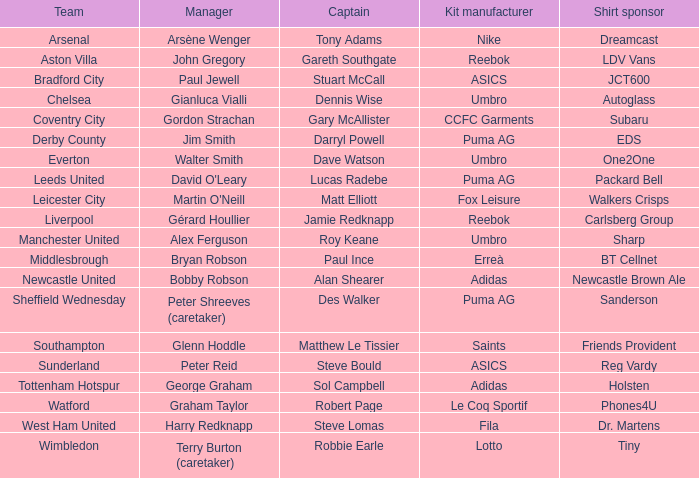Who is the captain managed by gianluca vialli? Dennis Wise. Parse the full table. {'header': ['Team', 'Manager', 'Captain', 'Kit manufacturer', 'Shirt sponsor'], 'rows': [['Arsenal', 'Arsène Wenger', 'Tony Adams', 'Nike', 'Dreamcast'], ['Aston Villa', 'John Gregory', 'Gareth Southgate', 'Reebok', 'LDV Vans'], ['Bradford City', 'Paul Jewell', 'Stuart McCall', 'ASICS', 'JCT600'], ['Chelsea', 'Gianluca Vialli', 'Dennis Wise', 'Umbro', 'Autoglass'], ['Coventry City', 'Gordon Strachan', 'Gary McAllister', 'CCFC Garments', 'Subaru'], ['Derby County', 'Jim Smith', 'Darryl Powell', 'Puma AG', 'EDS'], ['Everton', 'Walter Smith', 'Dave Watson', 'Umbro', 'One2One'], ['Leeds United', "David O'Leary", 'Lucas Radebe', 'Puma AG', 'Packard Bell'], ['Leicester City', "Martin O'Neill", 'Matt Elliott', 'Fox Leisure', 'Walkers Crisps'], ['Liverpool', 'Gérard Houllier', 'Jamie Redknapp', 'Reebok', 'Carlsberg Group'], ['Manchester United', 'Alex Ferguson', 'Roy Keane', 'Umbro', 'Sharp'], ['Middlesbrough', 'Bryan Robson', 'Paul Ince', 'Erreà', 'BT Cellnet'], ['Newcastle United', 'Bobby Robson', 'Alan Shearer', 'Adidas', 'Newcastle Brown Ale'], ['Sheffield Wednesday', 'Peter Shreeves (caretaker)', 'Des Walker', 'Puma AG', 'Sanderson'], ['Southampton', 'Glenn Hoddle', 'Matthew Le Tissier', 'Saints', 'Friends Provident'], ['Sunderland', 'Peter Reid', 'Steve Bould', 'ASICS', 'Reg Vardy'], ['Tottenham Hotspur', 'George Graham', 'Sol Campbell', 'Adidas', 'Holsten'], ['Watford', 'Graham Taylor', 'Robert Page', 'Le Coq Sportif', 'Phones4U'], ['West Ham United', 'Harry Redknapp', 'Steve Lomas', 'Fila', 'Dr. Martens'], ['Wimbledon', 'Terry Burton (caretaker)', 'Robbie Earle', 'Lotto', 'Tiny']]} 